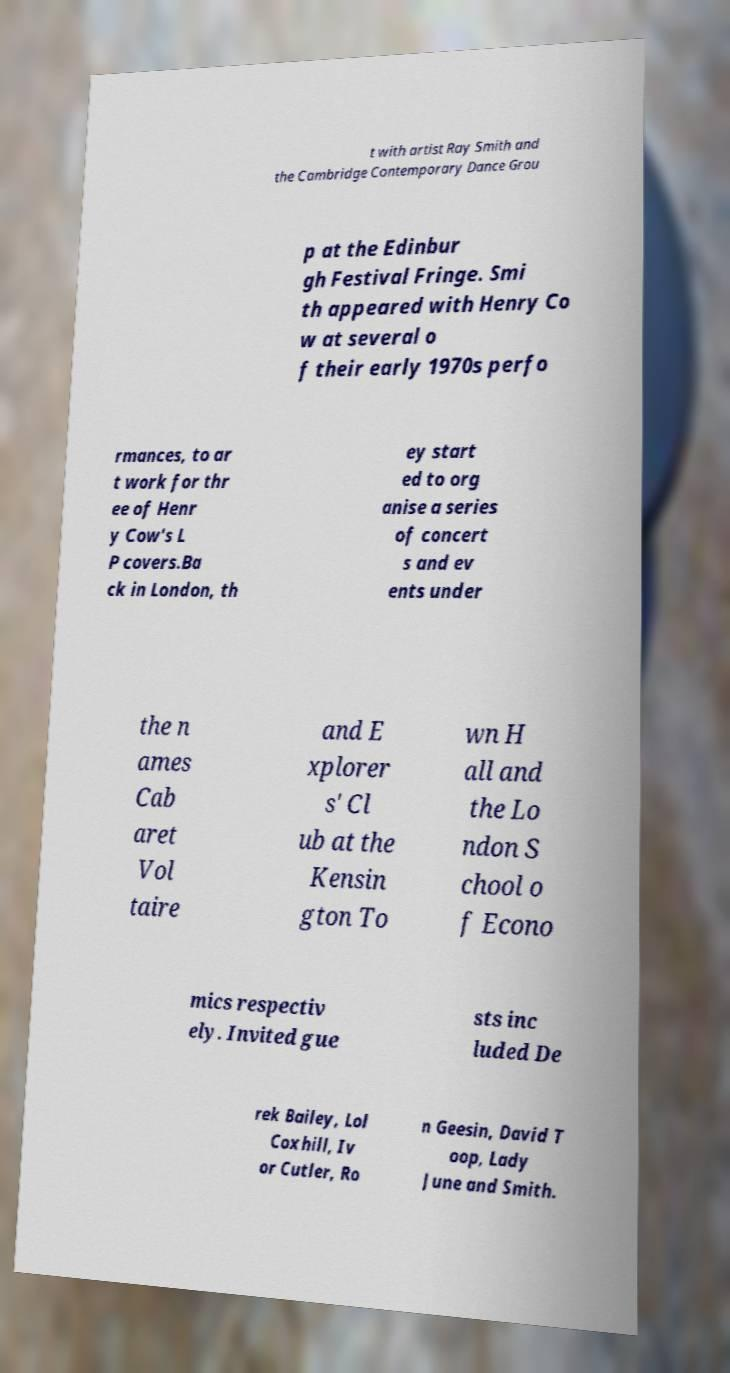Please identify and transcribe the text found in this image. t with artist Ray Smith and the Cambridge Contemporary Dance Grou p at the Edinbur gh Festival Fringe. Smi th appeared with Henry Co w at several o f their early 1970s perfo rmances, to ar t work for thr ee of Henr y Cow's L P covers.Ba ck in London, th ey start ed to org anise a series of concert s and ev ents under the n ames Cab aret Vol taire and E xplorer s' Cl ub at the Kensin gton To wn H all and the Lo ndon S chool o f Econo mics respectiv ely. Invited gue sts inc luded De rek Bailey, Lol Coxhill, Iv or Cutler, Ro n Geesin, David T oop, Lady June and Smith. 